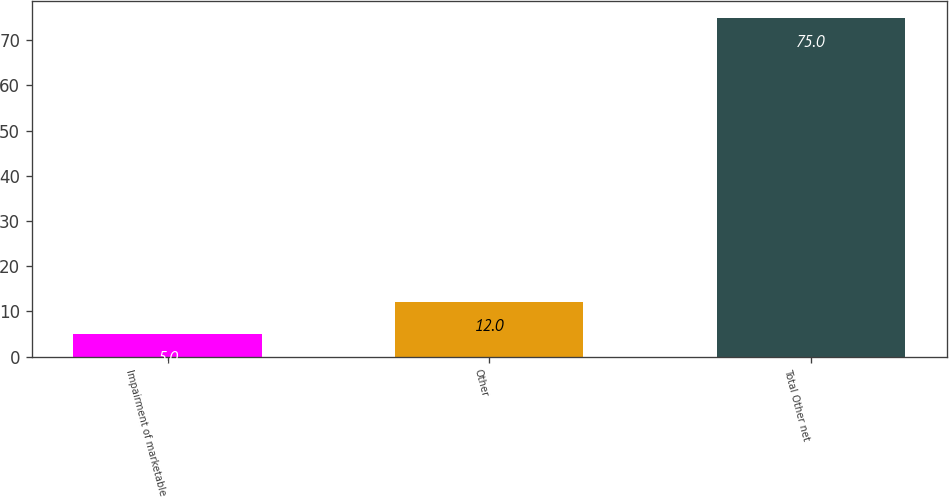<chart> <loc_0><loc_0><loc_500><loc_500><bar_chart><fcel>Impairment of marketable<fcel>Other<fcel>Total Other net<nl><fcel>5<fcel>12<fcel>75<nl></chart> 